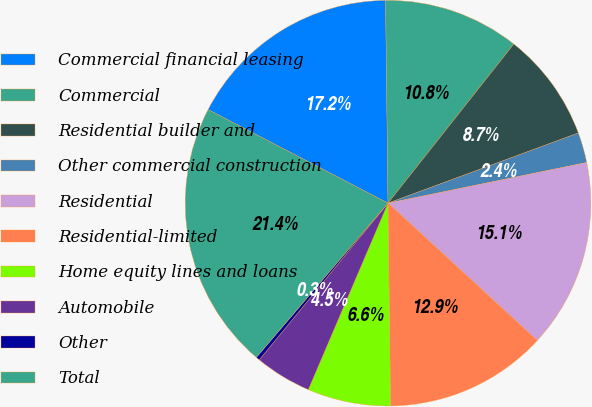<chart> <loc_0><loc_0><loc_500><loc_500><pie_chart><fcel>Commercial financial leasing<fcel>Commercial<fcel>Residential builder and<fcel>Other commercial construction<fcel>Residential<fcel>Residential-limited<fcel>Home equity lines and loans<fcel>Automobile<fcel>Other<fcel>Total<nl><fcel>17.17%<fcel>10.84%<fcel>8.73%<fcel>2.41%<fcel>15.06%<fcel>12.95%<fcel>6.63%<fcel>4.52%<fcel>0.3%<fcel>21.39%<nl></chart> 